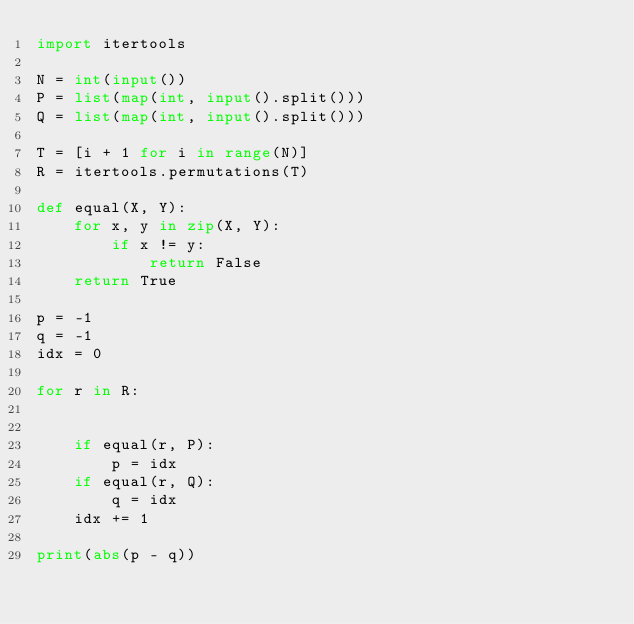<code> <loc_0><loc_0><loc_500><loc_500><_Python_>import itertools

N = int(input())
P = list(map(int, input().split()))
Q = list(map(int, input().split()))

T = [i + 1 for i in range(N)]
R = itertools.permutations(T)

def equal(X, Y):
    for x, y in zip(X, Y):
        if x != y:
            return False
    return True

p = -1
q = -1
idx = 0

for r in R:


    if equal(r, P):
        p = idx
    if equal(r, Q):
        q = idx
    idx += 1

print(abs(p - q))
</code> 